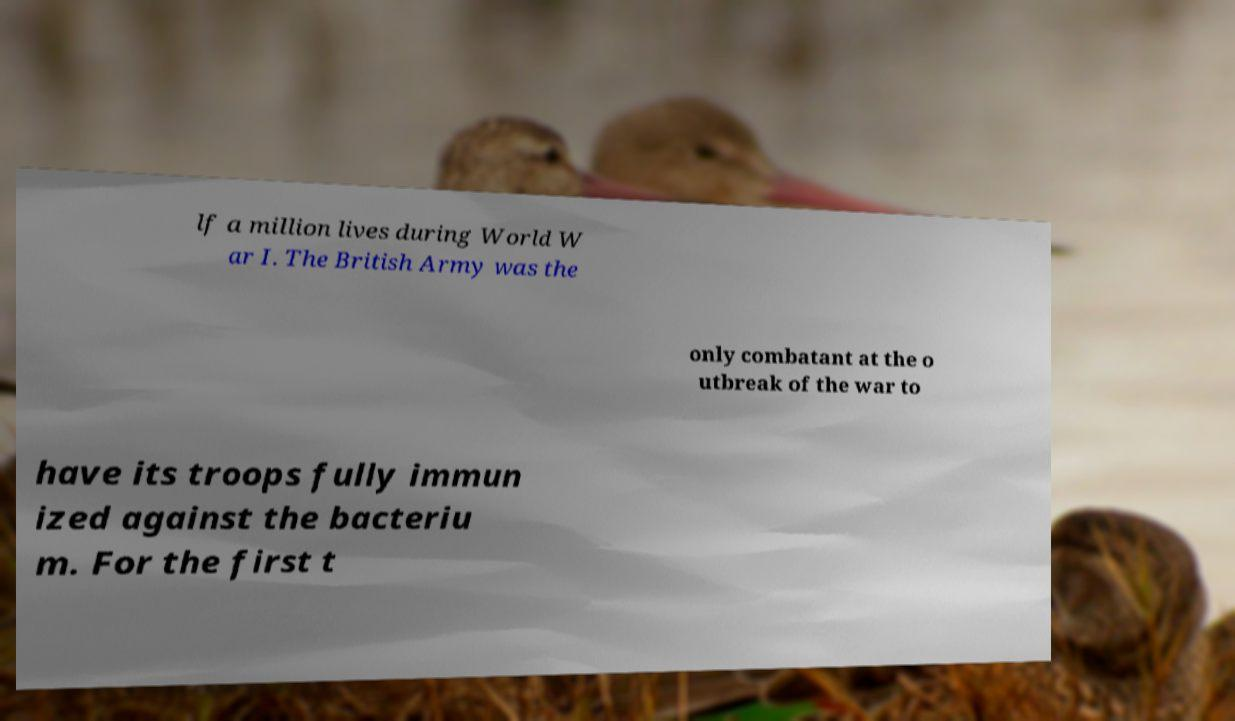Could you assist in decoding the text presented in this image and type it out clearly? lf a million lives during World W ar I. The British Army was the only combatant at the o utbreak of the war to have its troops fully immun ized against the bacteriu m. For the first t 